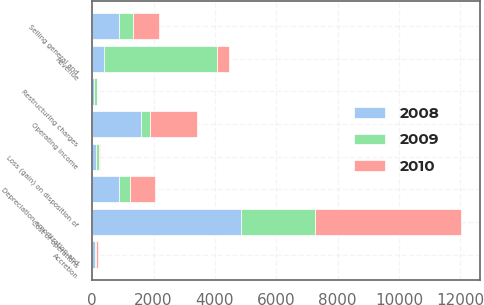Convert chart. <chart><loc_0><loc_0><loc_500><loc_500><stacked_bar_chart><ecel><fcel>Revenue<fcel>Cost of operations<fcel>Depreciation amortization and<fcel>Accretion<fcel>Selling general and<fcel>Loss (gain) on disposition of<fcel>Restructuring charges<fcel>Operating income<nl><fcel>2010<fcel>394.4<fcel>4764.8<fcel>833.7<fcel>80.5<fcel>858<fcel>19.1<fcel>11.4<fcel>1539.1<nl><fcel>2008<fcel>394.4<fcel>4844.2<fcel>869.7<fcel>88.8<fcel>880.4<fcel>137<fcel>63.2<fcel>1589.8<nl><fcel>2009<fcel>3685.1<fcel>2416.7<fcel>354.1<fcel>23.9<fcel>434.7<fcel>89.8<fcel>82.7<fcel>283.2<nl></chart> 